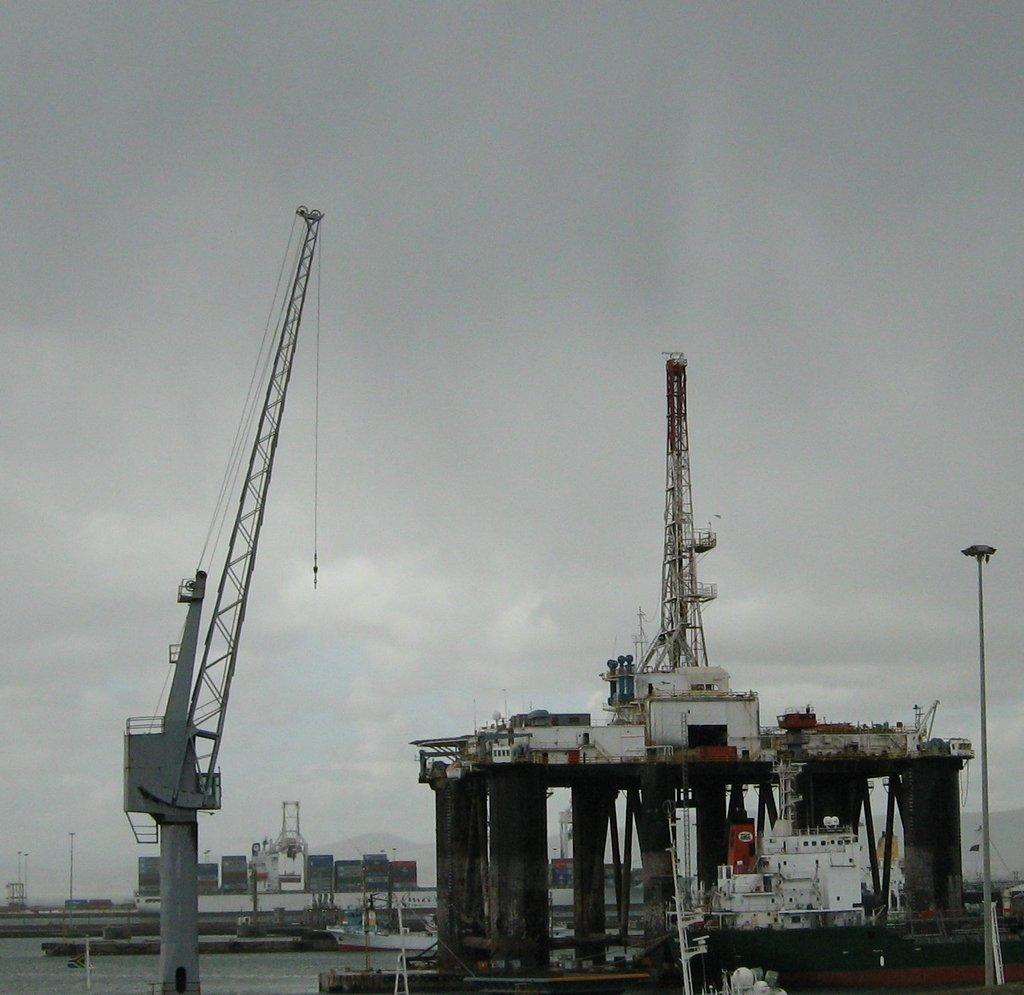What type of vehicles can be seen in the water in the image? There are ships in the water in the image. What are the ships carrying? Containers are present on one of the ships. What structures can be seen in the image? There are poles in the image. What can be seen illuminated in the image? There are lights in the image. What is visible in the background of the image? The sky is visible in the background of the image. How does the ship pull itself through the water in the image? Ships do not pull themselves through the water; they are propelled by engines or sails. 